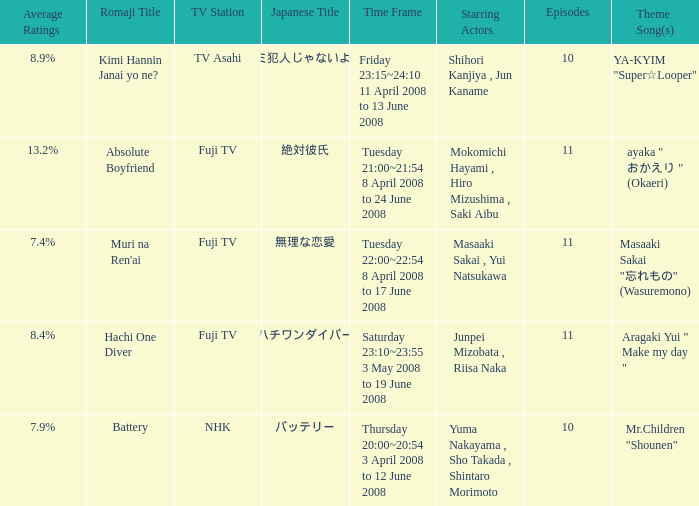Who were the starting actors in the time frame of  tuesday 22:00~22:54 8 april 2008 to 17 june 2008? Masaaki Sakai , Yui Natsukawa. 